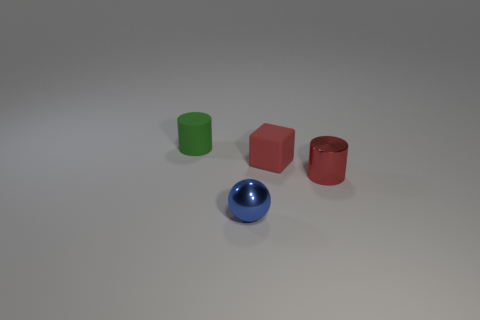Can you tell me the colors of the cylinders? Certainly! There are two cylinders in the image: one is green and the other is red. 